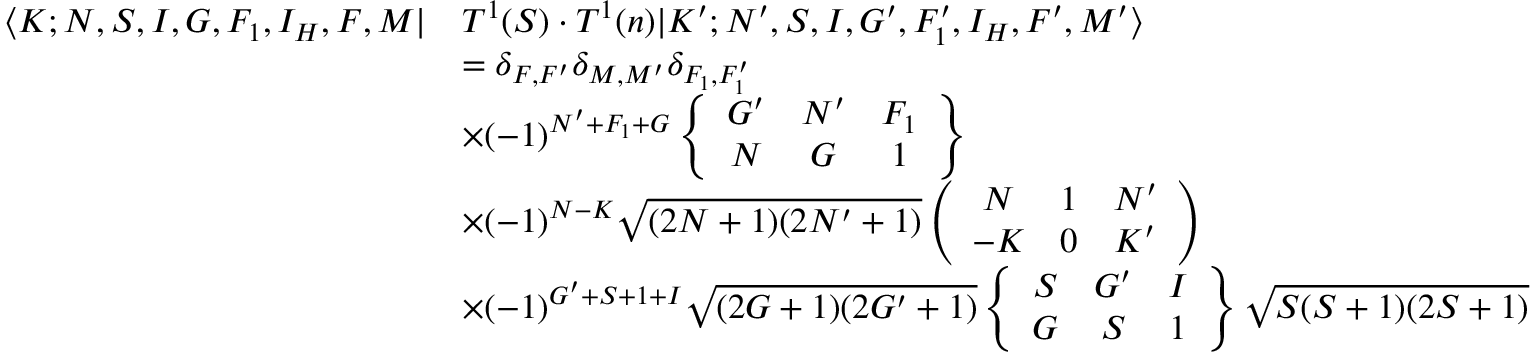Convert formula to latex. <formula><loc_0><loc_0><loc_500><loc_500>\begin{array} { r l } { \langle K ; N , S , I , G , F _ { 1 } , I _ { H } , F , M | } & { T ^ { 1 } ( S ) \cdot T ^ { 1 } ( n ) | K ^ { \prime } ; N ^ { \prime } , S , I , G ^ { \prime } , F _ { 1 } ^ { \prime } , I _ { H } , F ^ { \prime } , M ^ { \prime } \rangle } \\ & { = \delta _ { F , F ^ { \prime } } \delta _ { M , M ^ { \prime } } \delta _ { F _ { 1 } , F _ { 1 } ^ { \prime } } } \\ & { \times ( - 1 ) ^ { N ^ { \prime } + F _ { 1 } + G } \left \{ \begin{array} { c c c } { G ^ { \prime } } & { N ^ { \prime } } & { F _ { 1 } } \\ { N } & { G } & { 1 } \end{array} \right \} } \\ & { \times ( - 1 ) ^ { N - K } \sqrt { ( 2 N + 1 ) ( 2 N ^ { \prime } + 1 ) } \left ( \begin{array} { c c c } { N } & { 1 } & { N ^ { \prime } } \\ { - K } & { 0 } & { K ^ { \prime } } \end{array} \right ) } \\ & { \times ( - 1 ) ^ { G ^ { \prime } + S + 1 + I } \sqrt { ( 2 G + 1 ) ( 2 G ^ { \prime } + 1 ) } \left \{ \begin{array} { c c c } { S } & { G ^ { \prime } } & { I } \\ { G } & { S } & { 1 } \end{array} \right \} \sqrt { S ( S + 1 ) ( 2 S + 1 ) } } \end{array}</formula> 